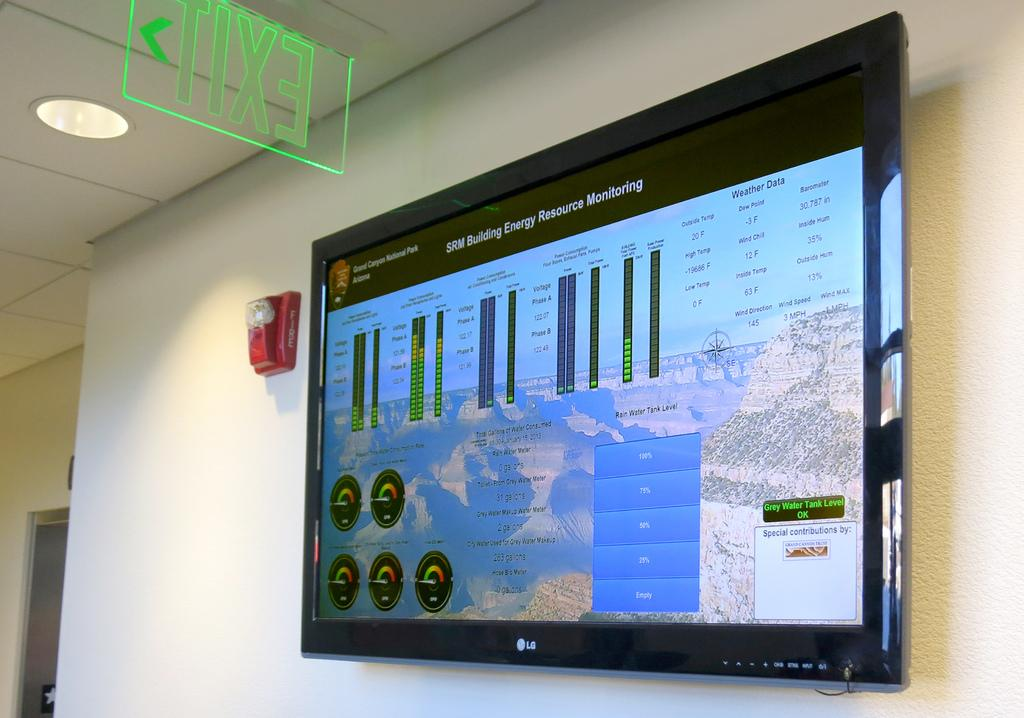<image>
Share a concise interpretation of the image provided. Large LG television hanging on a wall that says "Grand Canyon National Park". 